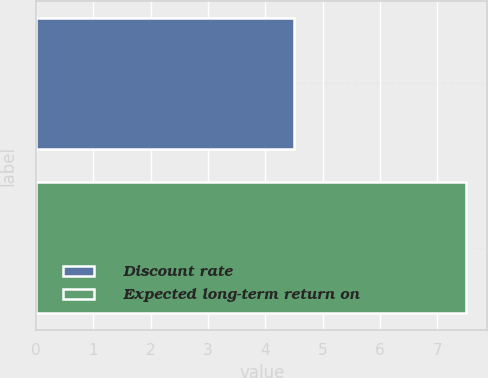<chart> <loc_0><loc_0><loc_500><loc_500><bar_chart><fcel>Discount rate<fcel>Expected long-term return on<nl><fcel>4.5<fcel>7.5<nl></chart> 